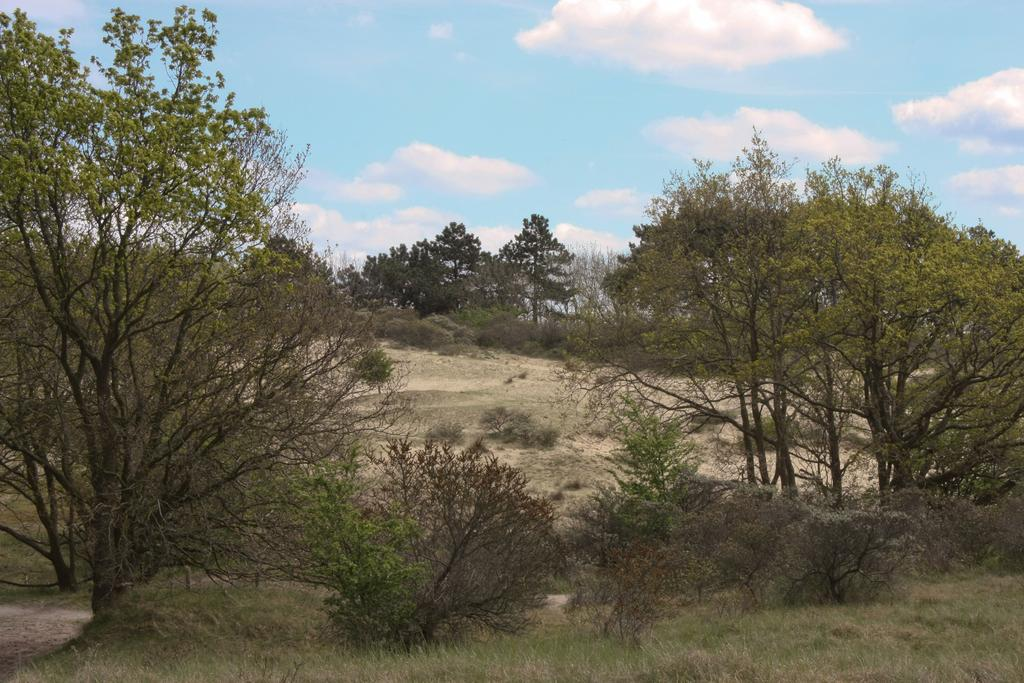What type of vegetation can be seen in the image? There is grass and plants visible in the image. What part of the natural environment is visible in the image? The ground is visible in the image. What can be seen in the background of the image? Trees and the sky are visible in the image. What is visible in the sky? Clouds are present in the sky. What type of jail can be seen in the image? There is no jail present in the image; it features natural elements such as grass, plants, trees, and the sky. What type of camp is depicted in the image? There is no camp present in the image; it features natural elements such as grass, plants, trees, and the sky. 